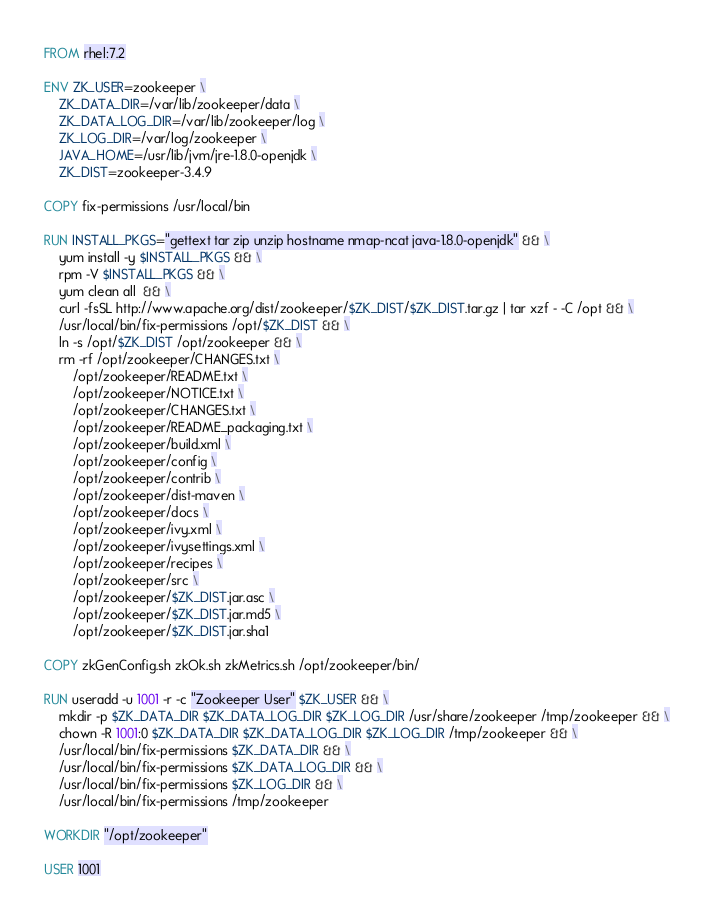<code> <loc_0><loc_0><loc_500><loc_500><_Dockerfile_>FROM rhel:7.2

ENV ZK_USER=zookeeper \
    ZK_DATA_DIR=/var/lib/zookeeper/data \
    ZK_DATA_LOG_DIR=/var/lib/zookeeper/log \
    ZK_LOG_DIR=/var/log/zookeeper \
    JAVA_HOME=/usr/lib/jvm/jre-1.8.0-openjdk \
    ZK_DIST=zookeeper-3.4.9

COPY fix-permissions /usr/local/bin

RUN INSTALL_PKGS="gettext tar zip unzip hostname nmap-ncat java-1.8.0-openjdk" && \
    yum install -y $INSTALL_PKGS && \
    rpm -V $INSTALL_PKGS && \
    yum clean all  && \
    curl -fsSL http://www.apache.org/dist/zookeeper/$ZK_DIST/$ZK_DIST.tar.gz | tar xzf - -C /opt && \
    /usr/local/bin/fix-permissions /opt/$ZK_DIST && \
    ln -s /opt/$ZK_DIST /opt/zookeeper && \
    rm -rf /opt/zookeeper/CHANGES.txt \
        /opt/zookeeper/README.txt \
        /opt/zookeeper/NOTICE.txt \
        /opt/zookeeper/CHANGES.txt \
        /opt/zookeeper/README_packaging.txt \
        /opt/zookeeper/build.xml \
        /opt/zookeeper/config \
        /opt/zookeeper/contrib \
        /opt/zookeeper/dist-maven \
        /opt/zookeeper/docs \
        /opt/zookeeper/ivy.xml \
        /opt/zookeeper/ivysettings.xml \
        /opt/zookeeper/recipes \
        /opt/zookeeper/src \
        /opt/zookeeper/$ZK_DIST.jar.asc \
        /opt/zookeeper/$ZK_DIST.jar.md5 \
        /opt/zookeeper/$ZK_DIST.jar.sha1

COPY zkGenConfig.sh zkOk.sh zkMetrics.sh /opt/zookeeper/bin/

RUN useradd -u 1001 -r -c "Zookeeper User" $ZK_USER && \
    mkdir -p $ZK_DATA_DIR $ZK_DATA_LOG_DIR $ZK_LOG_DIR /usr/share/zookeeper /tmp/zookeeper && \
    chown -R 1001:0 $ZK_DATA_DIR $ZK_DATA_LOG_DIR $ZK_LOG_DIR /tmp/zookeeper && \
    /usr/local/bin/fix-permissions $ZK_DATA_DIR && \
    /usr/local/bin/fix-permissions $ZK_DATA_LOG_DIR && \
    /usr/local/bin/fix-permissions $ZK_LOG_DIR && \
    /usr/local/bin/fix-permissions /tmp/zookeeper

WORKDIR "/opt/zookeeper"

USER 1001</code> 